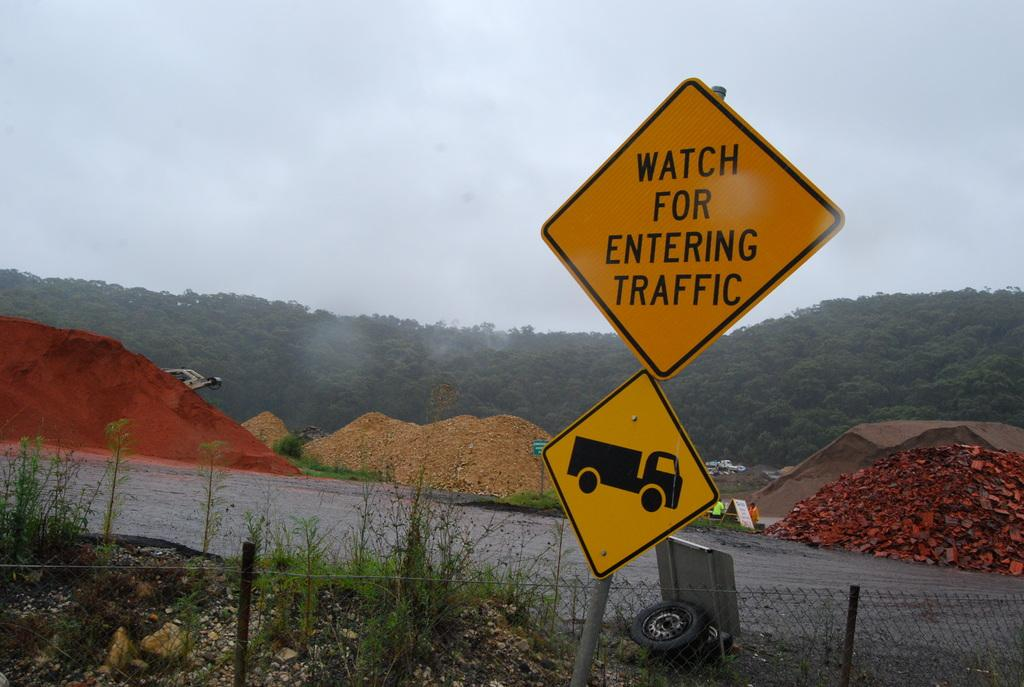What is present in the image that indicates a location or name? There is a name board and a signboard in the image. What structure can be seen in the image that might be used for support or stability? There is a pole in the image. What type of barrier can be seen in the image? There is a fence in the image. What type of natural elements can be seen in the image? There are plants, stones, and trees in the image. What type of surface is visible in the image? There is a road and soil visible in the image. What else can be seen in the image besides the mentioned elements? There are some objects in the image. What is visible in the background of the image? The sky is visible in the background of the image. How many pets are visible in the image? There are no pets present in the image. What type of laborer can be seen working in the image? There is no laborer present in the image. 